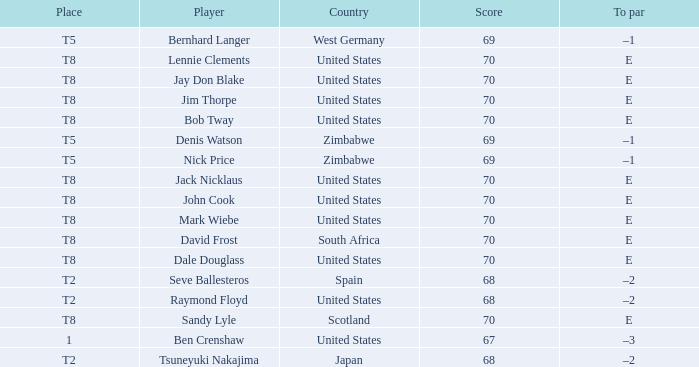What player has The United States as the country, with t2 as the place? Raymond Floyd. 